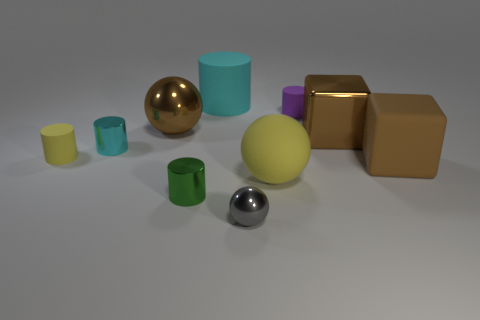Subtract all brown blocks. How many were subtracted if there are1brown blocks left? 1 Subtract all large yellow balls. How many balls are left? 2 Subtract all red blocks. How many cyan cylinders are left? 2 Subtract 2 cylinders. How many cylinders are left? 3 Subtract all green cylinders. How many cylinders are left? 4 Subtract all red cylinders. Subtract all yellow blocks. How many cylinders are left? 5 Subtract all spheres. How many objects are left? 7 Add 5 tiny gray shiny balls. How many tiny gray shiny balls exist? 6 Subtract 1 brown cubes. How many objects are left? 9 Subtract all small metallic things. Subtract all small green matte things. How many objects are left? 7 